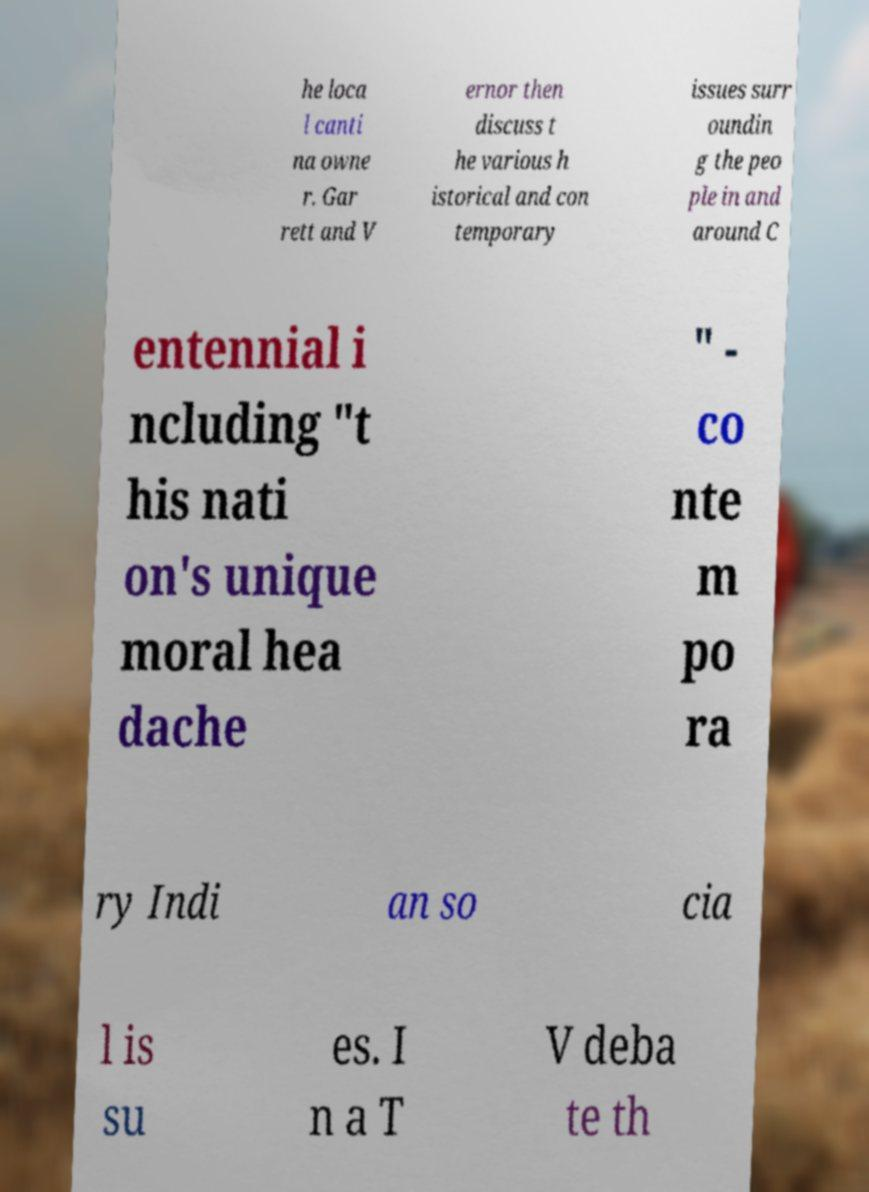Could you assist in decoding the text presented in this image and type it out clearly? he loca l canti na owne r. Gar rett and V ernor then discuss t he various h istorical and con temporary issues surr oundin g the peo ple in and around C entennial i ncluding "t his nati on's unique moral hea dache " - co nte m po ra ry Indi an so cia l is su es. I n a T V deba te th 